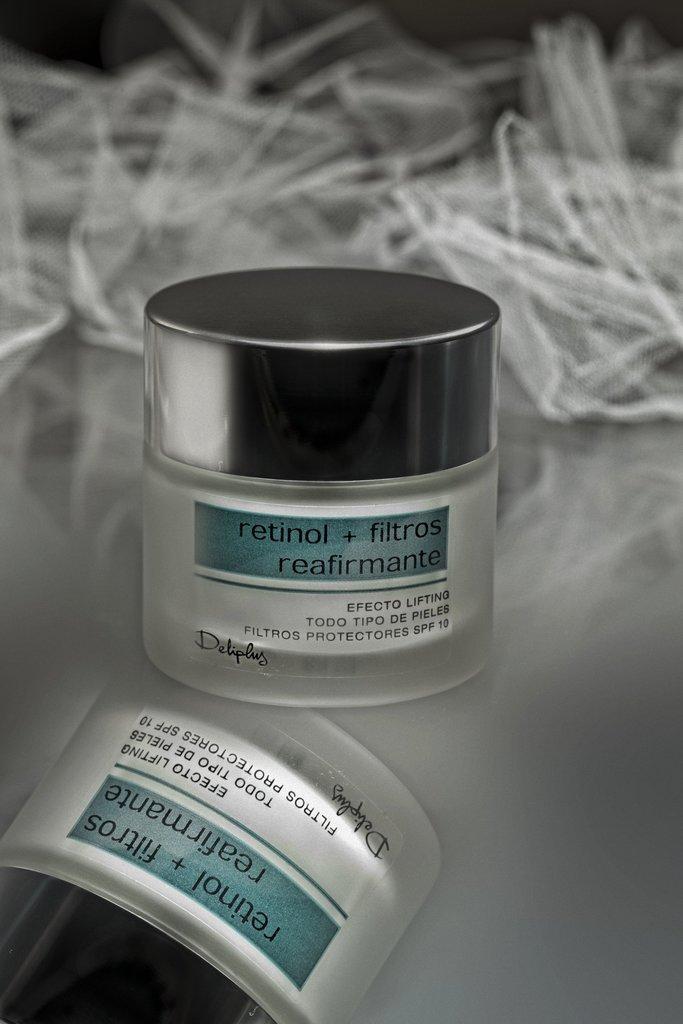In one or two sentences, can you explain what this image depicts? In this image, there is a mirror surface, on that there is a small box kept, on that there is RETINOL+FILTROS is written. 